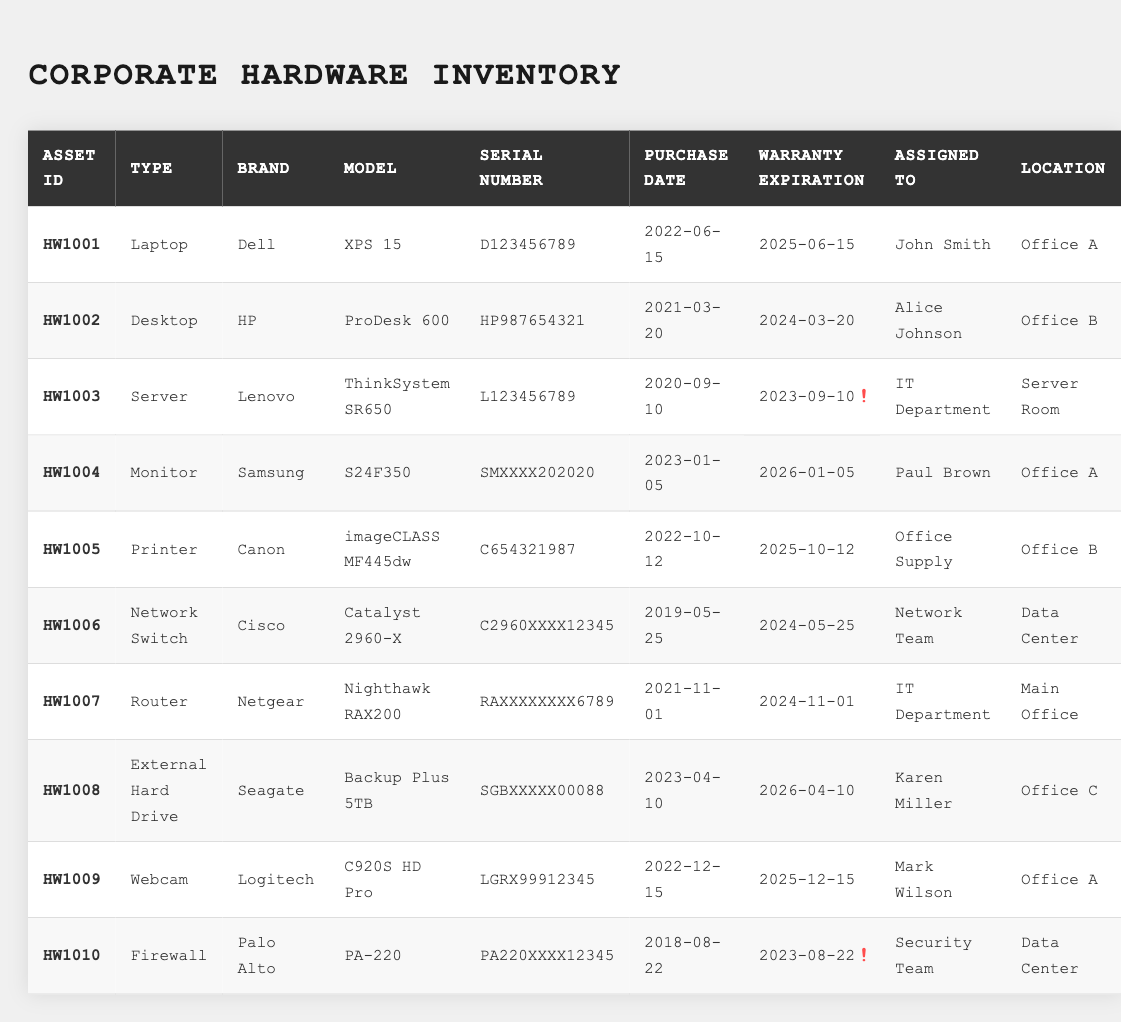What is the asset ID of the printer? The printer is listed in the table under "Asset ID." The row for the printer shows "HW1005" as its asset ID.
Answer: HW1005 Who is the assigned user of the Dell XPS 15 laptop? The Dell XPS 15 laptop is found under the row with the asset type "Laptop." The "Assigned To" column shows "John Smith" next to it.
Answer: John Smith What is the warranty expiration date for the Lenovo server? The warranty expiration date is found under the "Warranty Expiration" column for the Lenovo server (asset ID HW1003). It states "2023-09-10."
Answer: 2023-09-10 How many assets are assigned to the IT Department? The "Assigned To" column lists "IT Department" for two assets: the Lenovo server and the Netgear router. Thus, there are two assets assigned to that department.
Answer: 2 Is there an asset that was purchased before 2020? By looking at the "Purchase Date" column, the Lenovo server was purchased on "2020-09-10," but all other assets were purchased in 2020 or later, so the answer is no.
Answer: No Which asset has the earliest purchase date? The purchase dates for the assets show that the Canon printer is the earliest, purchased on "2022-10-12," while before that the Cisco network switch was purchased on "2019-05-25." Therefore, the correct answer is the network switch.
Answer: Cisco Network Switch What are the brands of the assets located in Office A? Scanning the "Location" column for "Office A," the brands listed are Dell (for the laptop), Samsung (for the monitor), and Logitech (for the webcam).
Answer: Dell, Samsung, Logitech Which asset will expire first, the Lenovo server or the Palo Alto firewall? The Lenovo server's warranty expiration date is "2023-09-10," and the Palo Alto firewall's is "2023-08-22." The firewall expires first, as its date comes before that of the server.
Answer: Palo Alto Firewall If a new external hard drive is needed, what is the purchase date of the Seagate Backup Plus? The table shows that the Seagate Backup Plus external hard drive was purchased on "2023-04-10." Thus, if a new one is considered, this date might be useful for referencing.
Answer: 2023-04-10 How many assets are there with warranties expiring in 2024? Looking at the "Warranty Expiration" column, two assets have expiration dates of "2024-03-20" (HP Desktop) and "2024-05-25" (Cisco Switch), which means there are two such assets.
Answer: 2 